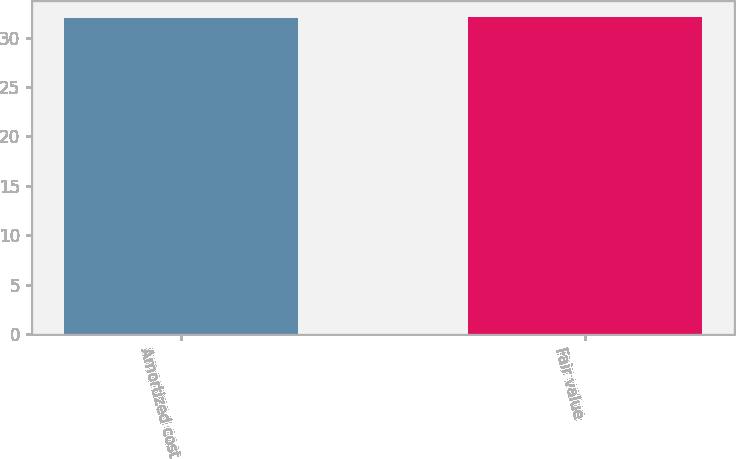<chart> <loc_0><loc_0><loc_500><loc_500><bar_chart><fcel>Amortized cost<fcel>Fair value<nl><fcel>32<fcel>32.1<nl></chart> 